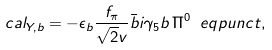Convert formula to latex. <formula><loc_0><loc_0><loc_500><loc_500>\L c a l _ { Y , b } = - \epsilon _ { b } \frac { f _ { \pi } } { \sqrt { 2 } v } { \bar { b } } i \gamma _ { 5 } b \, \Pi ^ { 0 } \ e q p u n c t ,</formula> 